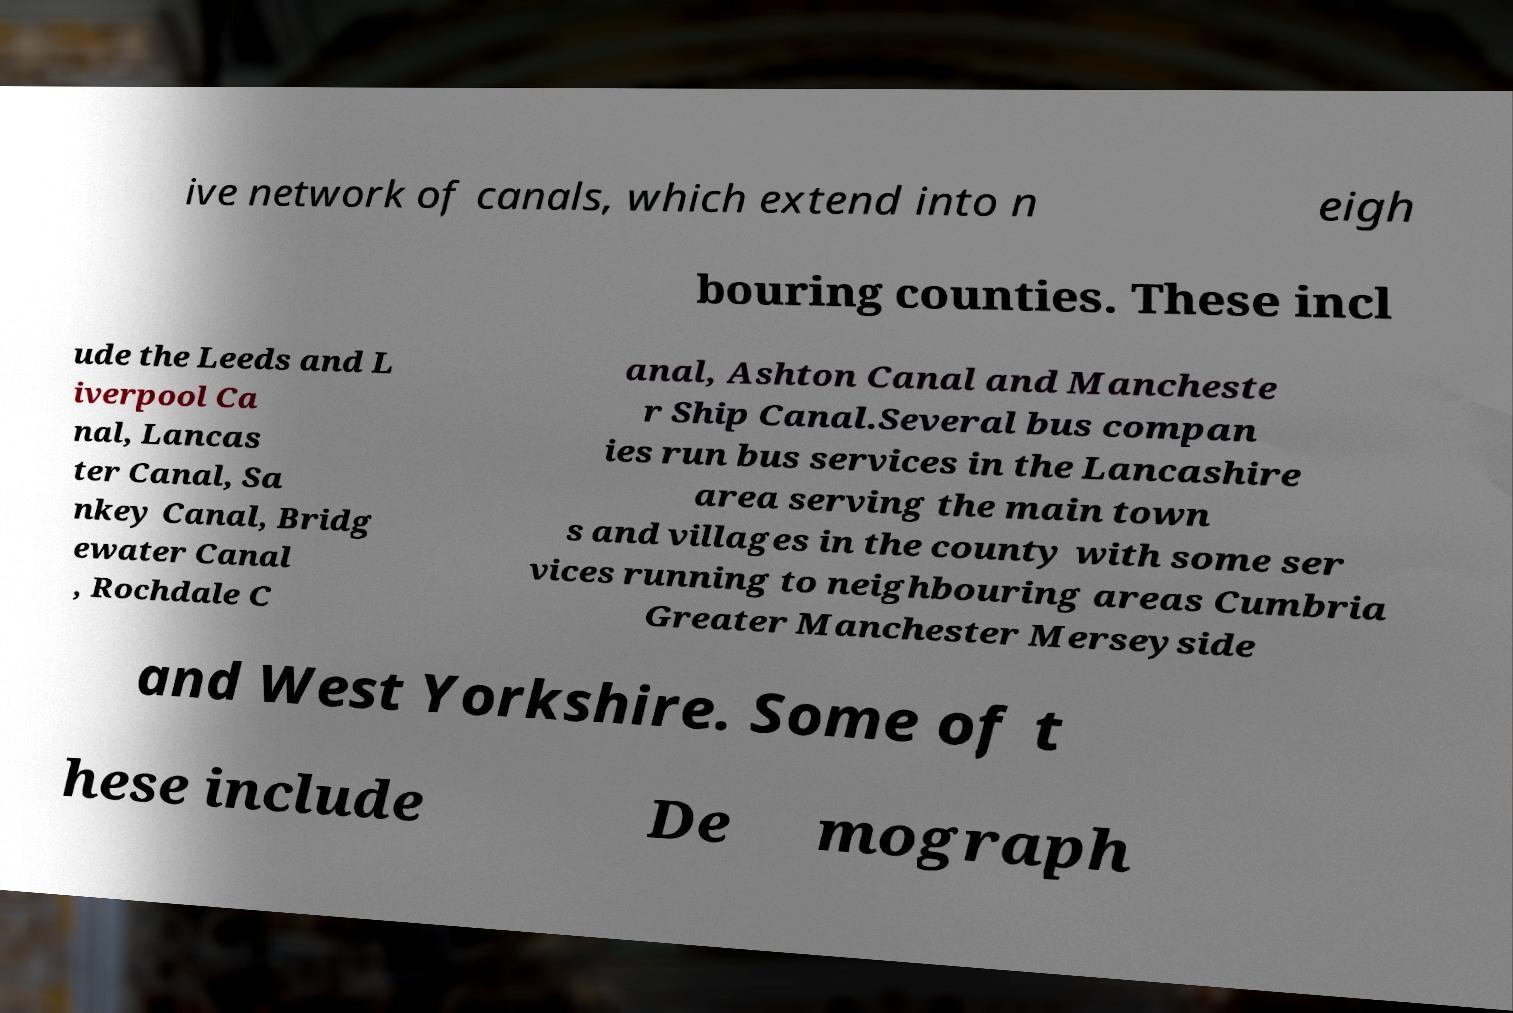Could you extract and type out the text from this image? ive network of canals, which extend into n eigh bouring counties. These incl ude the Leeds and L iverpool Ca nal, Lancas ter Canal, Sa nkey Canal, Bridg ewater Canal , Rochdale C anal, Ashton Canal and Mancheste r Ship Canal.Several bus compan ies run bus services in the Lancashire area serving the main town s and villages in the county with some ser vices running to neighbouring areas Cumbria Greater Manchester Merseyside and West Yorkshire. Some of t hese include De mograph 